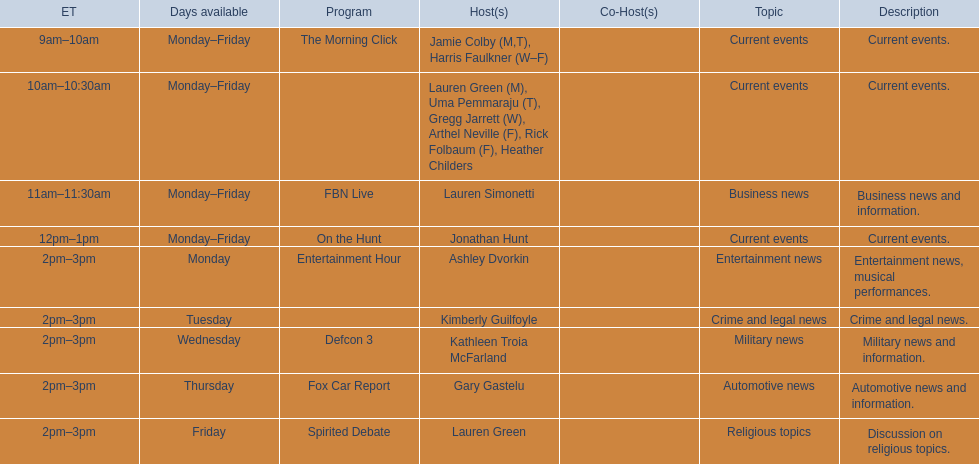Who are all of the hosts? Jamie Colby (M,T), Harris Faulkner (W–F), Lauren Green (M), Uma Pemmaraju (T), Gregg Jarrett (W), Arthel Neville (F), Rick Folbaum (F), Heather Childers, Lauren Simonetti, Jonathan Hunt, Ashley Dvorkin, Kimberly Guilfoyle, Kathleen Troia McFarland, Gary Gastelu, Lauren Green. Which hosts have shows on fridays? Jamie Colby (M,T), Harris Faulkner (W–F), Lauren Green (M), Uma Pemmaraju (T), Gregg Jarrett (W), Arthel Neville (F), Rick Folbaum (F), Heather Childers, Lauren Simonetti, Jonathan Hunt, Lauren Green. Of those, which host's show airs at 2pm? Lauren Green. 